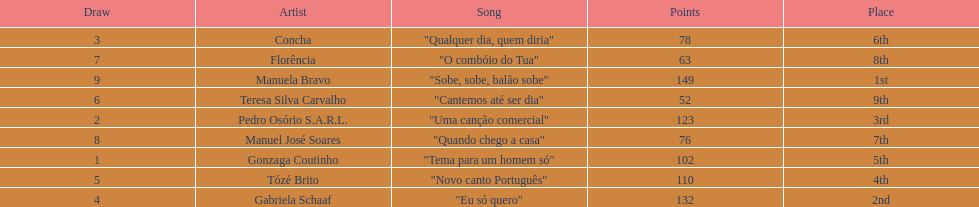Which artist came in last place? Teresa Silva Carvalho. Help me parse the entirety of this table. {'header': ['Draw', 'Artist', 'Song', 'Points', 'Place'], 'rows': [['3', 'Concha', '"Qualquer dia, quem diria"', '78', '6th'], ['7', 'Florência', '"O combóio do Tua"', '63', '8th'], ['9', 'Manuela Bravo', '"Sobe, sobe, balão sobe"', '149', '1st'], ['6', 'Teresa Silva Carvalho', '"Cantemos até ser dia"', '52', '9th'], ['2', 'Pedro Osório S.A.R.L.', '"Uma canção comercial"', '123', '3rd'], ['8', 'Manuel José Soares', '"Quando chego a casa"', '76', '7th'], ['1', 'Gonzaga Coutinho', '"Tema para um homem só"', '102', '5th'], ['5', 'Tózé Brito', '"Novo canto Português"', '110', '4th'], ['4', 'Gabriela Schaaf', '"Eu só quero"', '132', '2nd']]} 